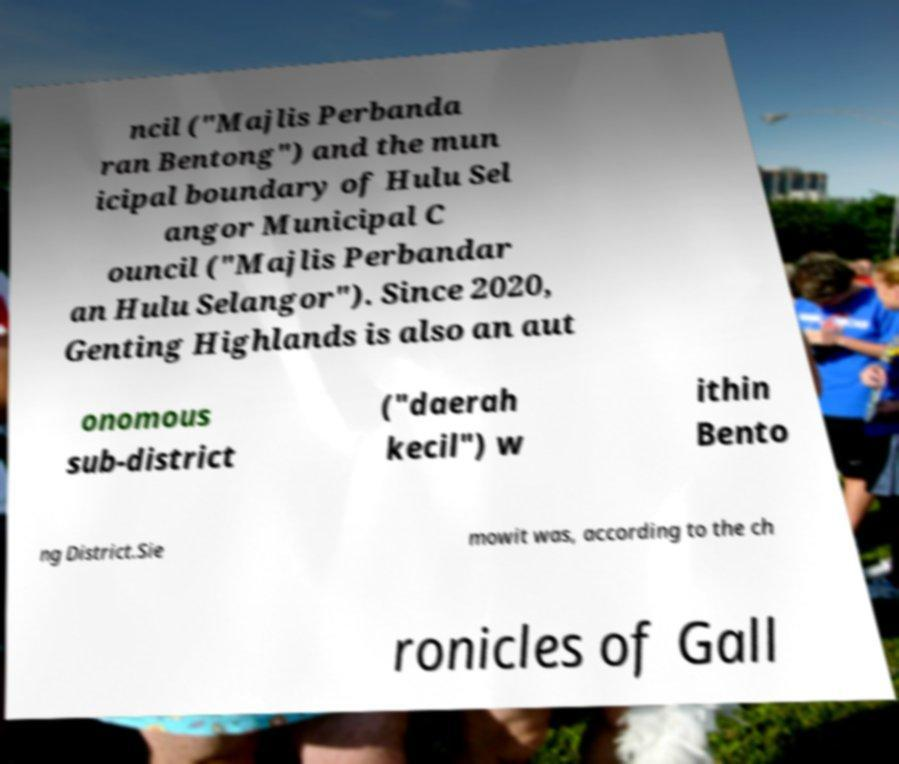There's text embedded in this image that I need extracted. Can you transcribe it verbatim? ncil ("Majlis Perbanda ran Bentong") and the mun icipal boundary of Hulu Sel angor Municipal C ouncil ("Majlis Perbandar an Hulu Selangor"). Since 2020, Genting Highlands is also an aut onomous sub-district ("daerah kecil") w ithin Bento ng District.Sie mowit was, according to the ch ronicles of Gall 